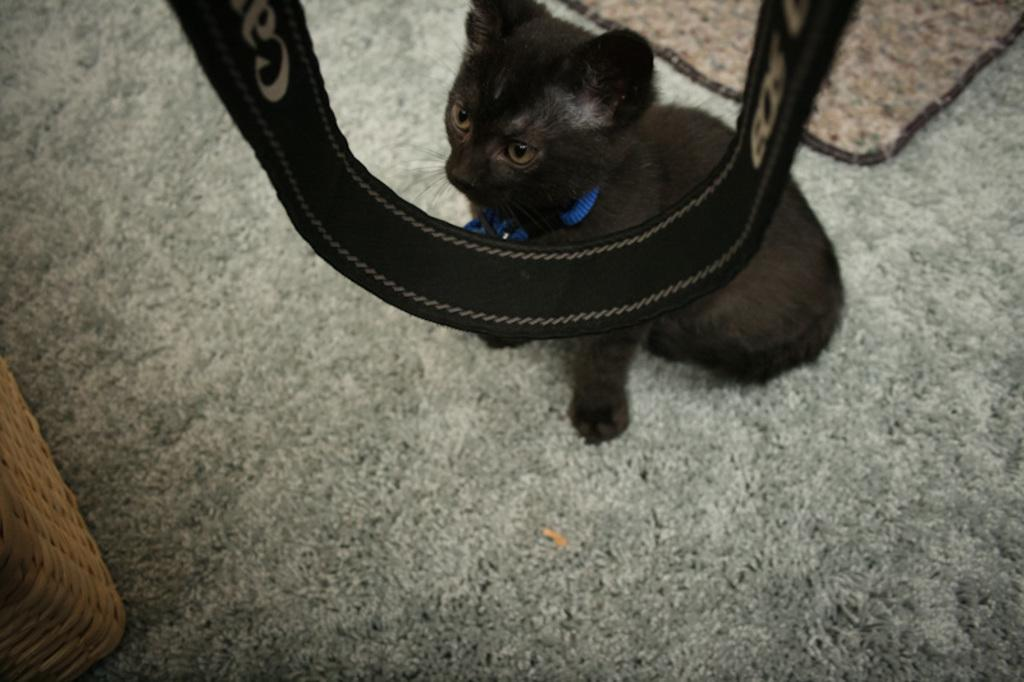What type of animal is on the mat in the image? There is a black cat on the mat in the image. What object is located at the center of the image? There is a canon bag at the center of the image. What can be seen on the left side of the image? There is a wooden box on the left side of the image. How does the cat establish a connection with the wooden box in the image? There is no indication in the image that the cat is establishing a connection with the wooden box. Can you describe the cat's walk in the image? The image does not show the cat walking; it is sitting on the mat. 